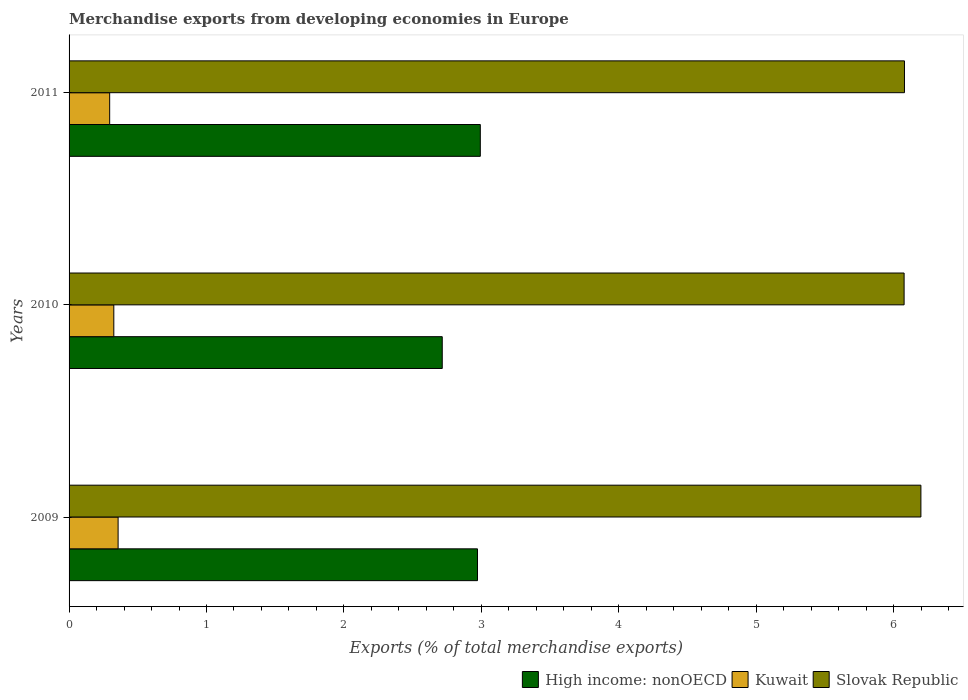How many groups of bars are there?
Your response must be concise. 3. How many bars are there on the 1st tick from the bottom?
Provide a short and direct response. 3. What is the label of the 3rd group of bars from the top?
Make the answer very short. 2009. What is the percentage of total merchandise exports in High income: nonOECD in 2010?
Your answer should be compact. 2.72. Across all years, what is the maximum percentage of total merchandise exports in Slovak Republic?
Your answer should be very brief. 6.2. Across all years, what is the minimum percentage of total merchandise exports in Kuwait?
Keep it short and to the point. 0.3. What is the total percentage of total merchandise exports in Slovak Republic in the graph?
Your answer should be very brief. 18.36. What is the difference between the percentage of total merchandise exports in Kuwait in 2009 and that in 2010?
Provide a succinct answer. 0.03. What is the difference between the percentage of total merchandise exports in High income: nonOECD in 2010 and the percentage of total merchandise exports in Kuwait in 2011?
Your answer should be very brief. 2.42. What is the average percentage of total merchandise exports in High income: nonOECD per year?
Keep it short and to the point. 2.89. In the year 2011, what is the difference between the percentage of total merchandise exports in High income: nonOECD and percentage of total merchandise exports in Kuwait?
Make the answer very short. 2.7. In how many years, is the percentage of total merchandise exports in Kuwait greater than 3.6 %?
Keep it short and to the point. 0. What is the ratio of the percentage of total merchandise exports in Slovak Republic in 2010 to that in 2011?
Make the answer very short. 1. Is the percentage of total merchandise exports in High income: nonOECD in 2009 less than that in 2011?
Keep it short and to the point. Yes. What is the difference between the highest and the second highest percentage of total merchandise exports in Slovak Republic?
Your answer should be compact. 0.12. What is the difference between the highest and the lowest percentage of total merchandise exports in Kuwait?
Keep it short and to the point. 0.06. In how many years, is the percentage of total merchandise exports in Kuwait greater than the average percentage of total merchandise exports in Kuwait taken over all years?
Provide a short and direct response. 1. Is the sum of the percentage of total merchandise exports in Slovak Republic in 2010 and 2011 greater than the maximum percentage of total merchandise exports in Kuwait across all years?
Make the answer very short. Yes. What does the 1st bar from the top in 2011 represents?
Offer a very short reply. Slovak Republic. What does the 2nd bar from the bottom in 2011 represents?
Keep it short and to the point. Kuwait. Is it the case that in every year, the sum of the percentage of total merchandise exports in Kuwait and percentage of total merchandise exports in Slovak Republic is greater than the percentage of total merchandise exports in High income: nonOECD?
Provide a succinct answer. Yes. How many bars are there?
Make the answer very short. 9. How many years are there in the graph?
Offer a terse response. 3. What is the difference between two consecutive major ticks on the X-axis?
Keep it short and to the point. 1. Are the values on the major ticks of X-axis written in scientific E-notation?
Offer a very short reply. No. Does the graph contain any zero values?
Offer a very short reply. No. Does the graph contain grids?
Provide a short and direct response. No. Where does the legend appear in the graph?
Offer a very short reply. Bottom right. What is the title of the graph?
Your answer should be very brief. Merchandise exports from developing economies in Europe. What is the label or title of the X-axis?
Your answer should be very brief. Exports (% of total merchandise exports). What is the Exports (% of total merchandise exports) of High income: nonOECD in 2009?
Keep it short and to the point. 2.97. What is the Exports (% of total merchandise exports) of Kuwait in 2009?
Offer a very short reply. 0.36. What is the Exports (% of total merchandise exports) of Slovak Republic in 2009?
Offer a very short reply. 6.2. What is the Exports (% of total merchandise exports) in High income: nonOECD in 2010?
Offer a terse response. 2.72. What is the Exports (% of total merchandise exports) of Kuwait in 2010?
Offer a terse response. 0.33. What is the Exports (% of total merchandise exports) of Slovak Republic in 2010?
Your response must be concise. 6.08. What is the Exports (% of total merchandise exports) in High income: nonOECD in 2011?
Give a very brief answer. 2.99. What is the Exports (% of total merchandise exports) of Kuwait in 2011?
Offer a terse response. 0.3. What is the Exports (% of total merchandise exports) of Slovak Republic in 2011?
Offer a terse response. 6.08. Across all years, what is the maximum Exports (% of total merchandise exports) in High income: nonOECD?
Give a very brief answer. 2.99. Across all years, what is the maximum Exports (% of total merchandise exports) of Kuwait?
Your response must be concise. 0.36. Across all years, what is the maximum Exports (% of total merchandise exports) of Slovak Republic?
Your answer should be compact. 6.2. Across all years, what is the minimum Exports (% of total merchandise exports) of High income: nonOECD?
Ensure brevity in your answer.  2.72. Across all years, what is the minimum Exports (% of total merchandise exports) of Kuwait?
Your answer should be compact. 0.3. Across all years, what is the minimum Exports (% of total merchandise exports) of Slovak Republic?
Make the answer very short. 6.08. What is the total Exports (% of total merchandise exports) of High income: nonOECD in the graph?
Keep it short and to the point. 8.68. What is the total Exports (% of total merchandise exports) of Kuwait in the graph?
Your response must be concise. 0.98. What is the total Exports (% of total merchandise exports) in Slovak Republic in the graph?
Provide a succinct answer. 18.36. What is the difference between the Exports (% of total merchandise exports) in High income: nonOECD in 2009 and that in 2010?
Offer a terse response. 0.26. What is the difference between the Exports (% of total merchandise exports) of Kuwait in 2009 and that in 2010?
Ensure brevity in your answer.  0.03. What is the difference between the Exports (% of total merchandise exports) of Slovak Republic in 2009 and that in 2010?
Provide a short and direct response. 0.12. What is the difference between the Exports (% of total merchandise exports) of High income: nonOECD in 2009 and that in 2011?
Ensure brevity in your answer.  -0.02. What is the difference between the Exports (% of total merchandise exports) in Kuwait in 2009 and that in 2011?
Your answer should be very brief. 0.06. What is the difference between the Exports (% of total merchandise exports) in Slovak Republic in 2009 and that in 2011?
Give a very brief answer. 0.12. What is the difference between the Exports (% of total merchandise exports) in High income: nonOECD in 2010 and that in 2011?
Make the answer very short. -0.28. What is the difference between the Exports (% of total merchandise exports) in Kuwait in 2010 and that in 2011?
Keep it short and to the point. 0.03. What is the difference between the Exports (% of total merchandise exports) of Slovak Republic in 2010 and that in 2011?
Offer a very short reply. -0. What is the difference between the Exports (% of total merchandise exports) in High income: nonOECD in 2009 and the Exports (% of total merchandise exports) in Kuwait in 2010?
Give a very brief answer. 2.65. What is the difference between the Exports (% of total merchandise exports) in High income: nonOECD in 2009 and the Exports (% of total merchandise exports) in Slovak Republic in 2010?
Offer a very short reply. -3.1. What is the difference between the Exports (% of total merchandise exports) of Kuwait in 2009 and the Exports (% of total merchandise exports) of Slovak Republic in 2010?
Offer a terse response. -5.72. What is the difference between the Exports (% of total merchandise exports) of High income: nonOECD in 2009 and the Exports (% of total merchandise exports) of Kuwait in 2011?
Make the answer very short. 2.68. What is the difference between the Exports (% of total merchandise exports) of High income: nonOECD in 2009 and the Exports (% of total merchandise exports) of Slovak Republic in 2011?
Your answer should be very brief. -3.11. What is the difference between the Exports (% of total merchandise exports) in Kuwait in 2009 and the Exports (% of total merchandise exports) in Slovak Republic in 2011?
Make the answer very short. -5.72. What is the difference between the Exports (% of total merchandise exports) in High income: nonOECD in 2010 and the Exports (% of total merchandise exports) in Kuwait in 2011?
Ensure brevity in your answer.  2.42. What is the difference between the Exports (% of total merchandise exports) in High income: nonOECD in 2010 and the Exports (% of total merchandise exports) in Slovak Republic in 2011?
Provide a short and direct response. -3.36. What is the difference between the Exports (% of total merchandise exports) in Kuwait in 2010 and the Exports (% of total merchandise exports) in Slovak Republic in 2011?
Ensure brevity in your answer.  -5.75. What is the average Exports (% of total merchandise exports) in High income: nonOECD per year?
Your response must be concise. 2.89. What is the average Exports (% of total merchandise exports) of Kuwait per year?
Ensure brevity in your answer.  0.33. What is the average Exports (% of total merchandise exports) in Slovak Republic per year?
Provide a short and direct response. 6.12. In the year 2009, what is the difference between the Exports (% of total merchandise exports) in High income: nonOECD and Exports (% of total merchandise exports) in Kuwait?
Make the answer very short. 2.62. In the year 2009, what is the difference between the Exports (% of total merchandise exports) of High income: nonOECD and Exports (% of total merchandise exports) of Slovak Republic?
Make the answer very short. -3.23. In the year 2009, what is the difference between the Exports (% of total merchandise exports) in Kuwait and Exports (% of total merchandise exports) in Slovak Republic?
Your response must be concise. -5.84. In the year 2010, what is the difference between the Exports (% of total merchandise exports) in High income: nonOECD and Exports (% of total merchandise exports) in Kuwait?
Give a very brief answer. 2.39. In the year 2010, what is the difference between the Exports (% of total merchandise exports) in High income: nonOECD and Exports (% of total merchandise exports) in Slovak Republic?
Keep it short and to the point. -3.36. In the year 2010, what is the difference between the Exports (% of total merchandise exports) in Kuwait and Exports (% of total merchandise exports) in Slovak Republic?
Ensure brevity in your answer.  -5.75. In the year 2011, what is the difference between the Exports (% of total merchandise exports) of High income: nonOECD and Exports (% of total merchandise exports) of Kuwait?
Offer a very short reply. 2.7. In the year 2011, what is the difference between the Exports (% of total merchandise exports) in High income: nonOECD and Exports (% of total merchandise exports) in Slovak Republic?
Provide a short and direct response. -3.09. In the year 2011, what is the difference between the Exports (% of total merchandise exports) of Kuwait and Exports (% of total merchandise exports) of Slovak Republic?
Offer a terse response. -5.78. What is the ratio of the Exports (% of total merchandise exports) in High income: nonOECD in 2009 to that in 2010?
Offer a terse response. 1.09. What is the ratio of the Exports (% of total merchandise exports) of Kuwait in 2009 to that in 2010?
Your answer should be very brief. 1.1. What is the ratio of the Exports (% of total merchandise exports) in Slovak Republic in 2009 to that in 2010?
Keep it short and to the point. 1.02. What is the ratio of the Exports (% of total merchandise exports) in High income: nonOECD in 2009 to that in 2011?
Keep it short and to the point. 0.99. What is the ratio of the Exports (% of total merchandise exports) of Kuwait in 2009 to that in 2011?
Your answer should be compact. 1.21. What is the ratio of the Exports (% of total merchandise exports) in Slovak Republic in 2009 to that in 2011?
Offer a very short reply. 1.02. What is the ratio of the Exports (% of total merchandise exports) of High income: nonOECD in 2010 to that in 2011?
Give a very brief answer. 0.91. What is the ratio of the Exports (% of total merchandise exports) in Kuwait in 2010 to that in 2011?
Ensure brevity in your answer.  1.1. What is the difference between the highest and the second highest Exports (% of total merchandise exports) in High income: nonOECD?
Offer a very short reply. 0.02. What is the difference between the highest and the second highest Exports (% of total merchandise exports) of Kuwait?
Provide a succinct answer. 0.03. What is the difference between the highest and the second highest Exports (% of total merchandise exports) in Slovak Republic?
Make the answer very short. 0.12. What is the difference between the highest and the lowest Exports (% of total merchandise exports) in High income: nonOECD?
Keep it short and to the point. 0.28. What is the difference between the highest and the lowest Exports (% of total merchandise exports) of Kuwait?
Your response must be concise. 0.06. What is the difference between the highest and the lowest Exports (% of total merchandise exports) in Slovak Republic?
Offer a very short reply. 0.12. 